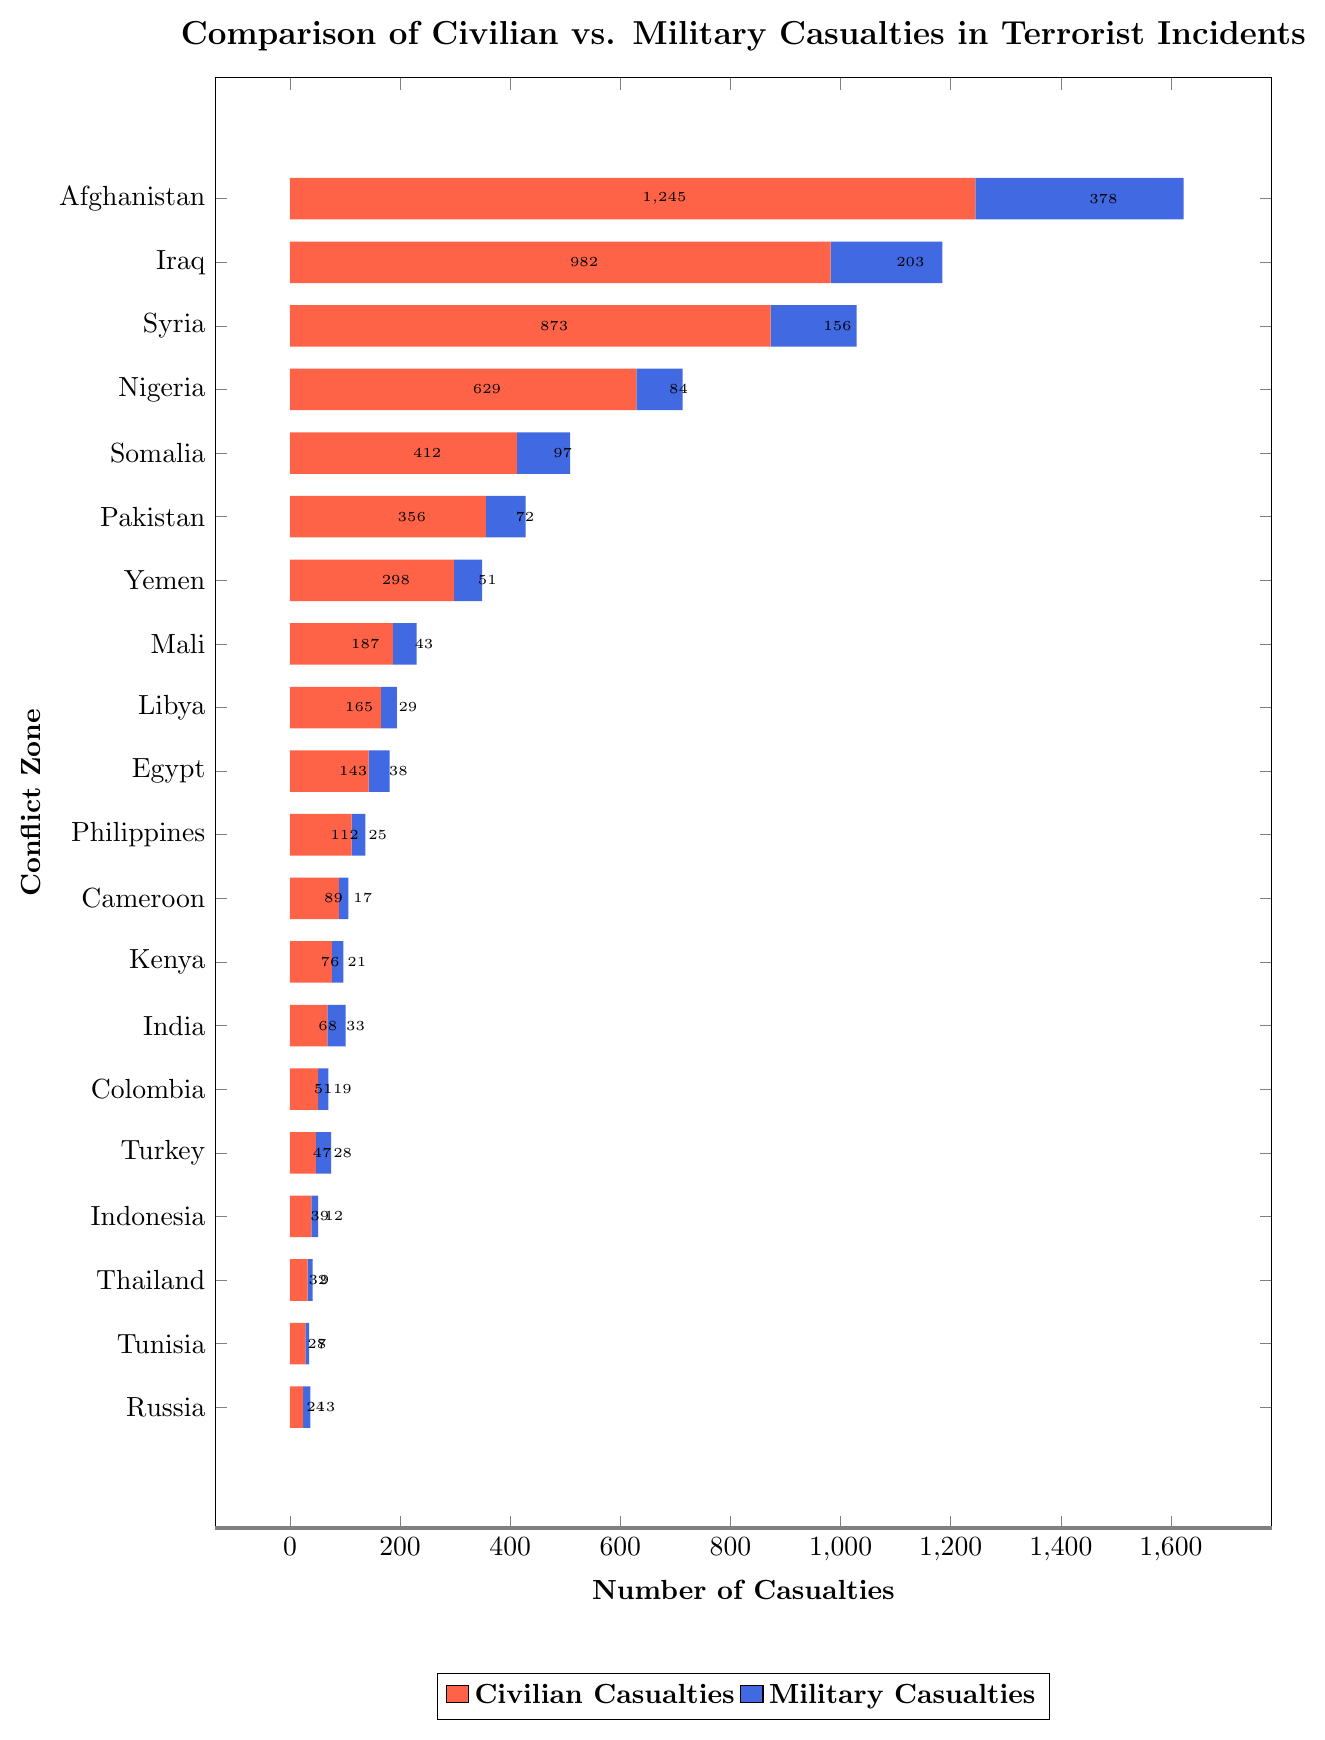What is the total number of civilian casualties and military casualties in Afghanistan? From the plot, the number of civilian casualties in Afghanistan is 1245, and the number of military casualties is 378. Summing them up gives 1245 + 378.
Answer: 1623 Which conflict zone has the highest number of civilian casualties? From the plot, the bar representing civilian casualties for Afghanistan is the longest among all, indicating it has the highest number of civilian casualties.
Answer: Afghanistan How many more civilian casualties are there compared to military casualties in Syria? From the plot, the number of civilian casualties in Syria is 873, and the number of military casualties is 156. The difference is 873 - 156.
Answer: 717 In which conflict zone do military casualties almost equal the civilian casualties? From the plot, Turkey is the conflict zone where civilian casualties are 47, and military casualties are 28, showing the closest proportion.
Answer: Turkey Which conflict zone has the smallest difference between civilian and military casualties, and what is that difference? From the plot, Turkey has civilian casualties at 47 and military casualties at 28, giving a difference of 47 - 28. This is the smallest difference compared to other zones.
Answer: Turkey, 19 What is the average number of military casualties across all conflict zones? From the plot, the military casualties are listed for each zone. Summing them up gives (378 + 203 + 156 + 84 + 97 + 72 + 51 + 43 + 29 + 38 + 25 + 17 + 21 + 33 + 19 + 28 + 12 + 9 + 7 + 13) = 1337. There are 20 conflict zones, so the average is 1337 / 20.
Answer: 66.85 In which conflict zone are the civilian casualties the smallest, and what is the number? From the plot, Russia has the shortest bar for civilian casualties, which is 24, indicating it has the smallest number of civilian casualties.
Answer: Russia, 24 If we consider civilian casualties as being represented in red and military casualties in blue, which conflict zone has the most visually balanced bar in terms of color height? From the plot, Turkey has civilian casualties (red) at 47 and military casualties (blue) at 28, making it appear visually the most balanced in terms of color height.
Answer: Turkey Compare the combined civilian and military casualties in Nigeria and Somalia. Which is greater and by how much? From the plot, Nigeria has 629 civilian and 84 military casualties, totaling 713. Somalia has 412 civilian and 97 military casualties, totaling 509. The difference is 713 - 509.
Answer: Nigeria, by 204 